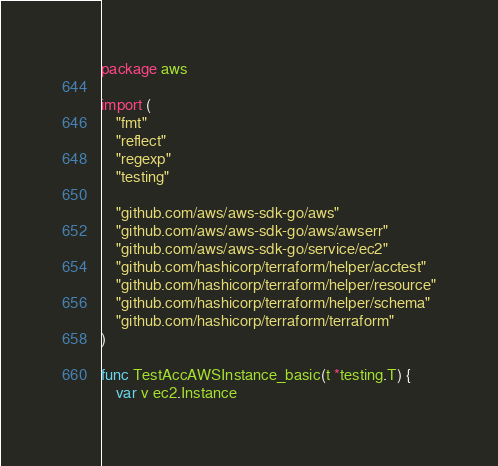<code> <loc_0><loc_0><loc_500><loc_500><_Go_>package aws

import (
	"fmt"
	"reflect"
	"regexp"
	"testing"

	"github.com/aws/aws-sdk-go/aws"
	"github.com/aws/aws-sdk-go/aws/awserr"
	"github.com/aws/aws-sdk-go/service/ec2"
	"github.com/hashicorp/terraform/helper/acctest"
	"github.com/hashicorp/terraform/helper/resource"
	"github.com/hashicorp/terraform/helper/schema"
	"github.com/hashicorp/terraform/terraform"
)

func TestAccAWSInstance_basic(t *testing.T) {
	var v ec2.Instance</code> 